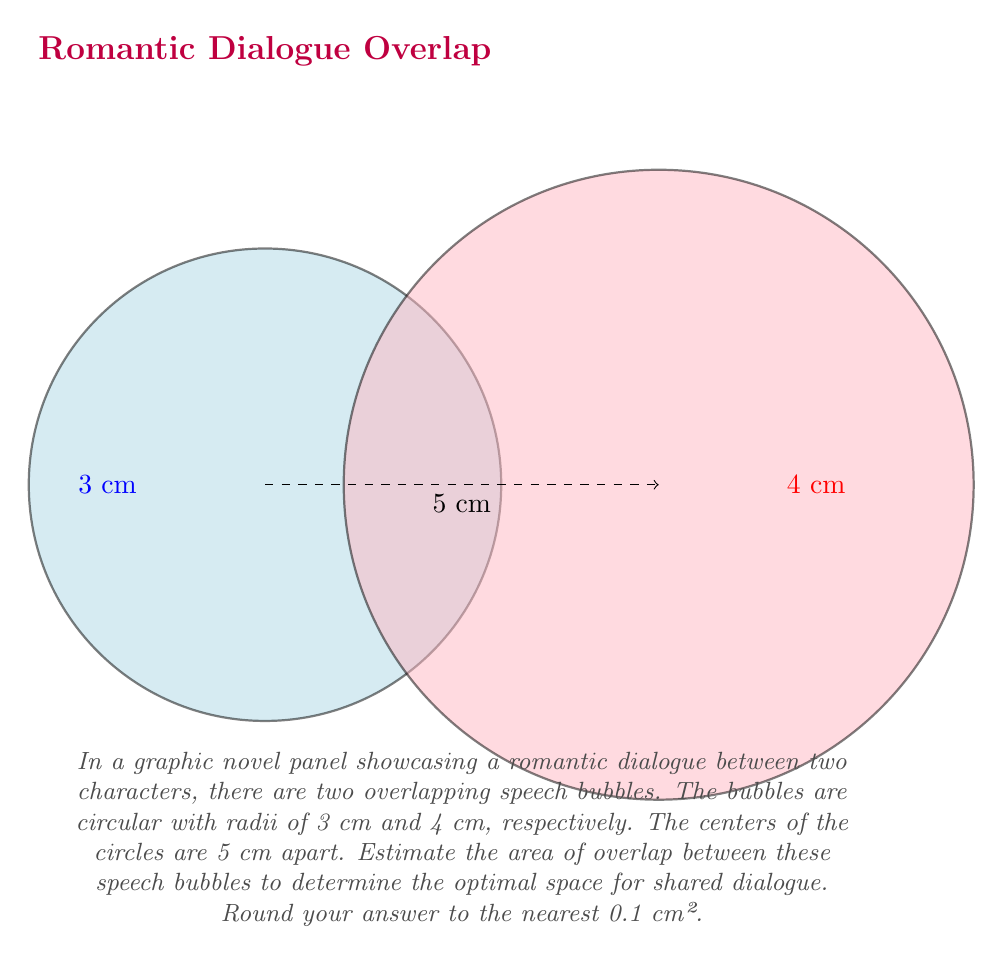Show me your answer to this math problem. To estimate the overlap area of two intersecting circles, we can use the following steps:

1) First, we need to calculate the distance between the centers of the circles (d) and the radii (r₁ and r₂):
   d = 5 cm, r₁ = 3 cm, r₂ = 4 cm

2) Next, we calculate the angles θ₁ and θ₂ using the law of cosines:

   $$\cos(\theta_1) = \frac{r_1^2 + d^2 - r_2^2}{2r_1d}$$
   $$\cos(\theta_2) = \frac{r_2^2 + d^2 - r_1^2}{2r_2d}$$

   θ₁ = 2 * arccos((3² + 5² - 4²) / (2 * 3 * 5)) ≈ 2.0944 radians
   θ₂ = 2 * arccos((4² + 5² - 3²) / (2 * 4 * 5)) ≈ 1.8545 radians

3) Now we can calculate the areas of the circular sectors:

   $$A_1 = \frac{1}{2}r_1^2\theta_1 \approx 9.4248 \text{ cm}^2$$
   $$A_2 = \frac{1}{2}r_2^2\theta_2 \approx 14.8360 \text{ cm}^2$$

4) Calculate the areas of the triangles:

   $$T_1 = \frac{1}{2}r_1^2\sin(\theta_1) \approx 4.3301 \text{ cm}^2$$
   $$T_2 = \frac{1}{2}r_2^2\sin(\theta_2) \approx 7.1539 \text{ cm}^2$$

5) The overlap area is the sum of the circular sectors minus the sum of the triangles:

   Overlap Area = (A₁ + A₂) - (T₁ + T₂)
                ≈ (9.4248 + 14.8360) - (4.3301 + 7.1539)
                ≈ 12.7768 cm²

6) Rounding to the nearest 0.1 cm²:
   12.8 cm²
Answer: 12.8 cm² 